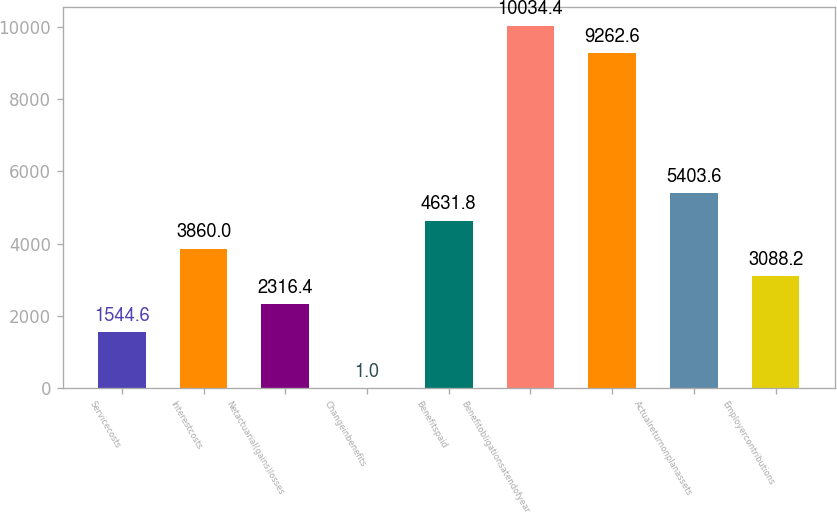Convert chart. <chart><loc_0><loc_0><loc_500><loc_500><bar_chart><fcel>Servicecosts<fcel>Interestcosts<fcel>Netactuarial(gains)losses<fcel>Changeinbenefits<fcel>Benefitspaid<fcel>Benefitobligationsatendofyear<fcel>Unnamed: 6<fcel>Actualreturnonplanassets<fcel>Employercontributions<nl><fcel>1544.6<fcel>3860<fcel>2316.4<fcel>1<fcel>4631.8<fcel>10034.4<fcel>9262.6<fcel>5403.6<fcel>3088.2<nl></chart> 